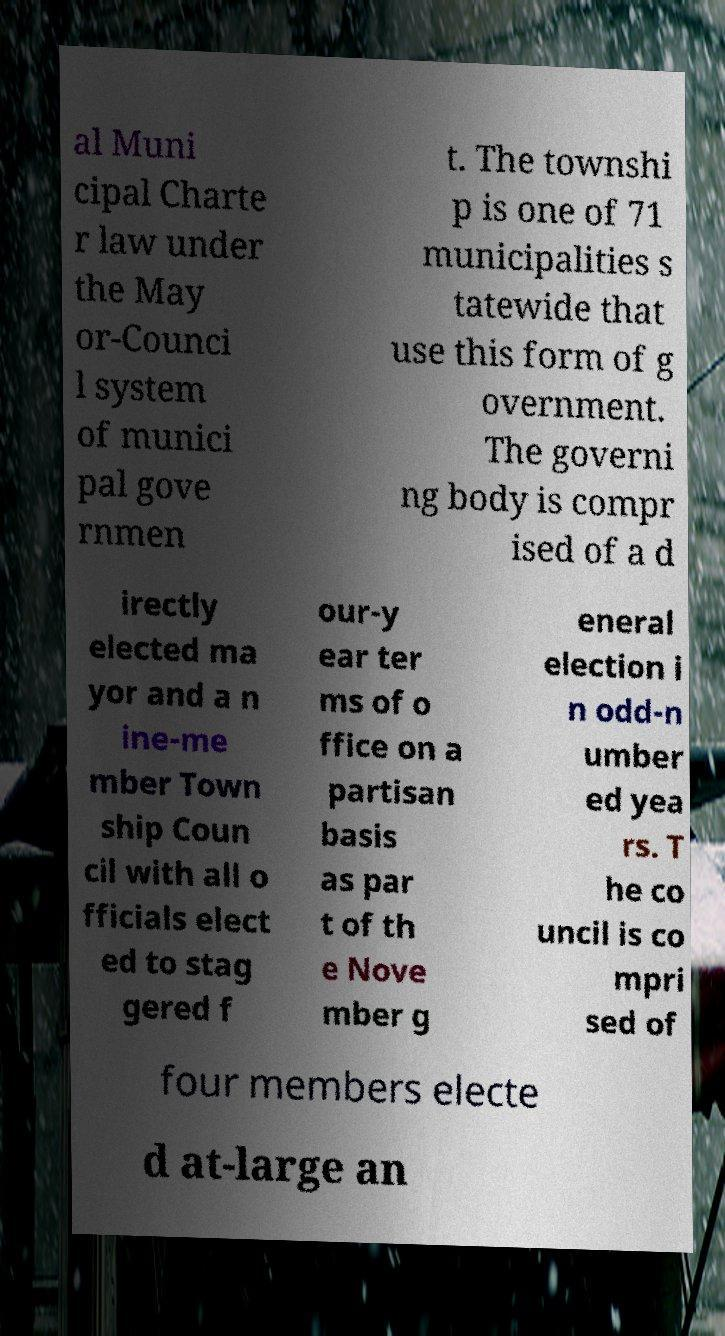Could you assist in decoding the text presented in this image and type it out clearly? al Muni cipal Charte r law under the May or-Counci l system of munici pal gove rnmen t. The townshi p is one of 71 municipalities s tatewide that use this form of g overnment. The governi ng body is compr ised of a d irectly elected ma yor and a n ine-me mber Town ship Coun cil with all o fficials elect ed to stag gered f our-y ear ter ms of o ffice on a partisan basis as par t of th e Nove mber g eneral election i n odd-n umber ed yea rs. T he co uncil is co mpri sed of four members electe d at-large an 